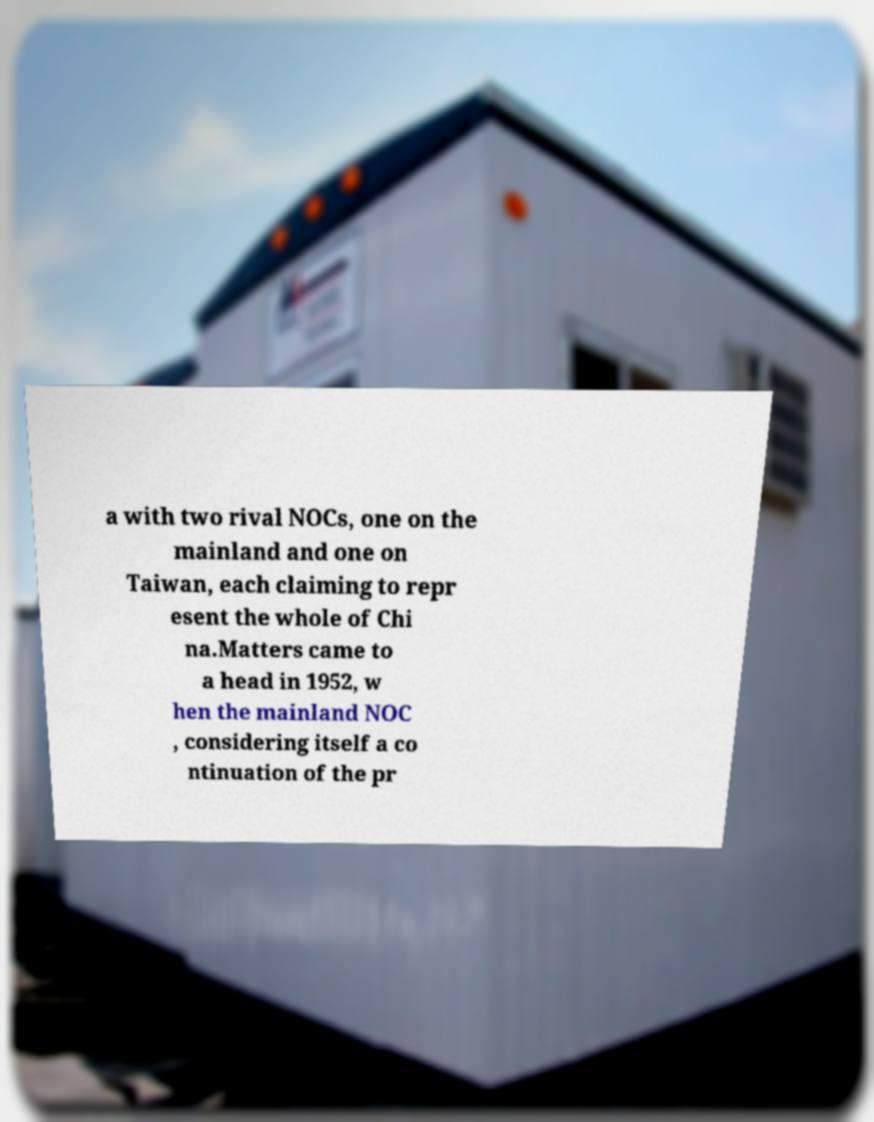Please identify and transcribe the text found in this image. a with two rival NOCs, one on the mainland and one on Taiwan, each claiming to repr esent the whole of Chi na.Matters came to a head in 1952, w hen the mainland NOC , considering itself a co ntinuation of the pr 